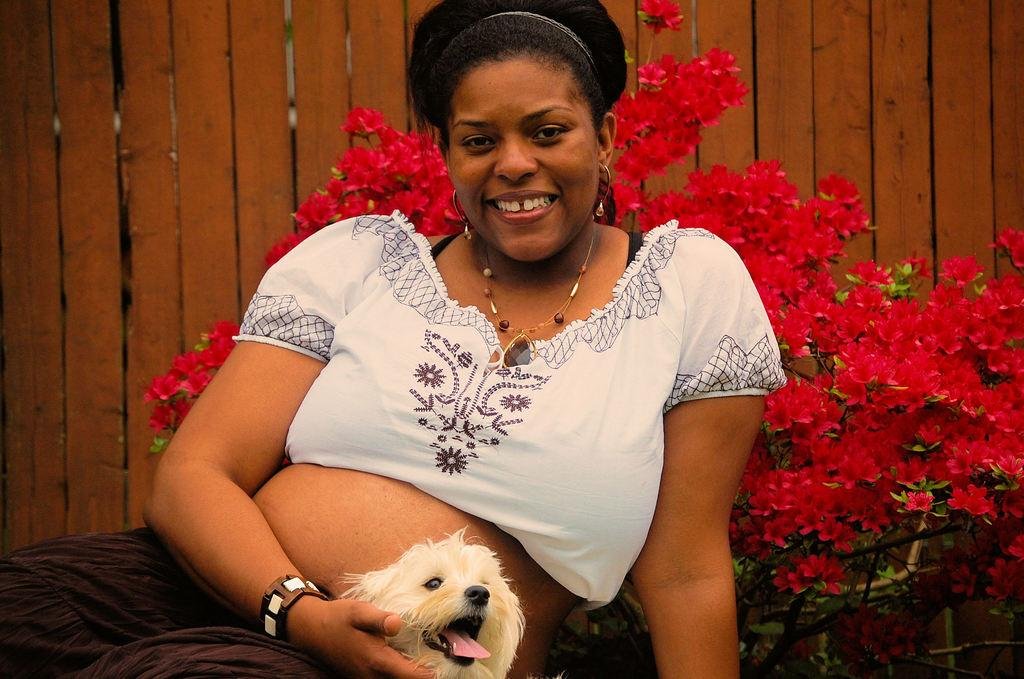What type of flowers can be seen in the image? There are red color flowers in the image. What animal is present in the image? There is a white color dog in the image. What is the woman wearing in the image? The woman is wearing a white color dress in the image. What material can be seen in the image? There are wooden sticks visible in the image. What type of scene is being depicted in the image? The image does not depict a specific scene; it simply shows red flowers, a white dog, a woman in a white dress, and wooden sticks. How is the division of labor represented in the image? The image does not depict any division of labor; it is a still image with no action or interaction between subjects. 